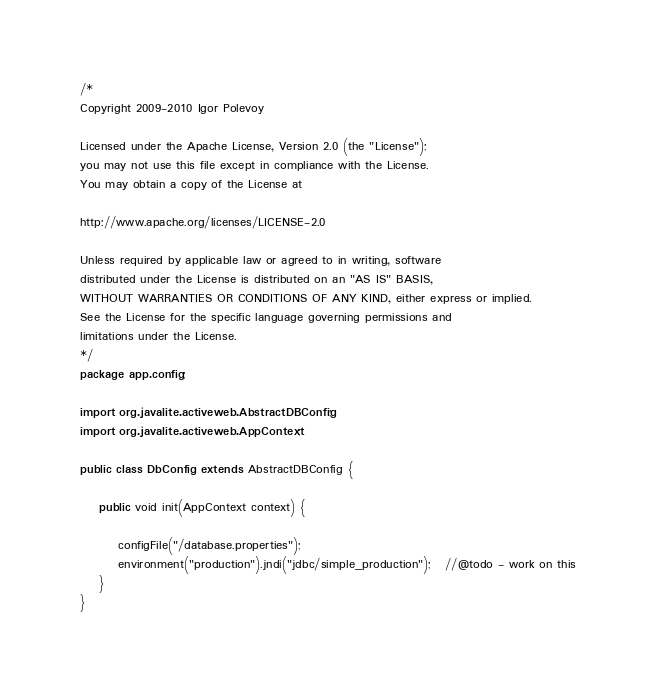Convert code to text. <code><loc_0><loc_0><loc_500><loc_500><_Java_>/*
Copyright 2009-2010 Igor Polevoy 

Licensed under the Apache License, Version 2.0 (the "License"); 
you may not use this file except in compliance with the License. 
You may obtain a copy of the License at 

http://www.apache.org/licenses/LICENSE-2.0 

Unless required by applicable law or agreed to in writing, software 
distributed under the License is distributed on an "AS IS" BASIS, 
WITHOUT WARRANTIES OR CONDITIONS OF ANY KIND, either express or implied. 
See the License for the specific language governing permissions and 
limitations under the License. 
*/
package app.config;

import org.javalite.activeweb.AbstractDBConfig;
import org.javalite.activeweb.AppContext;

public class DbConfig extends AbstractDBConfig {

    public void init(AppContext context) {

        configFile("/database.properties");
        environment("production").jndi("jdbc/simple_production");   //@todo - work on this
    }
}
</code> 